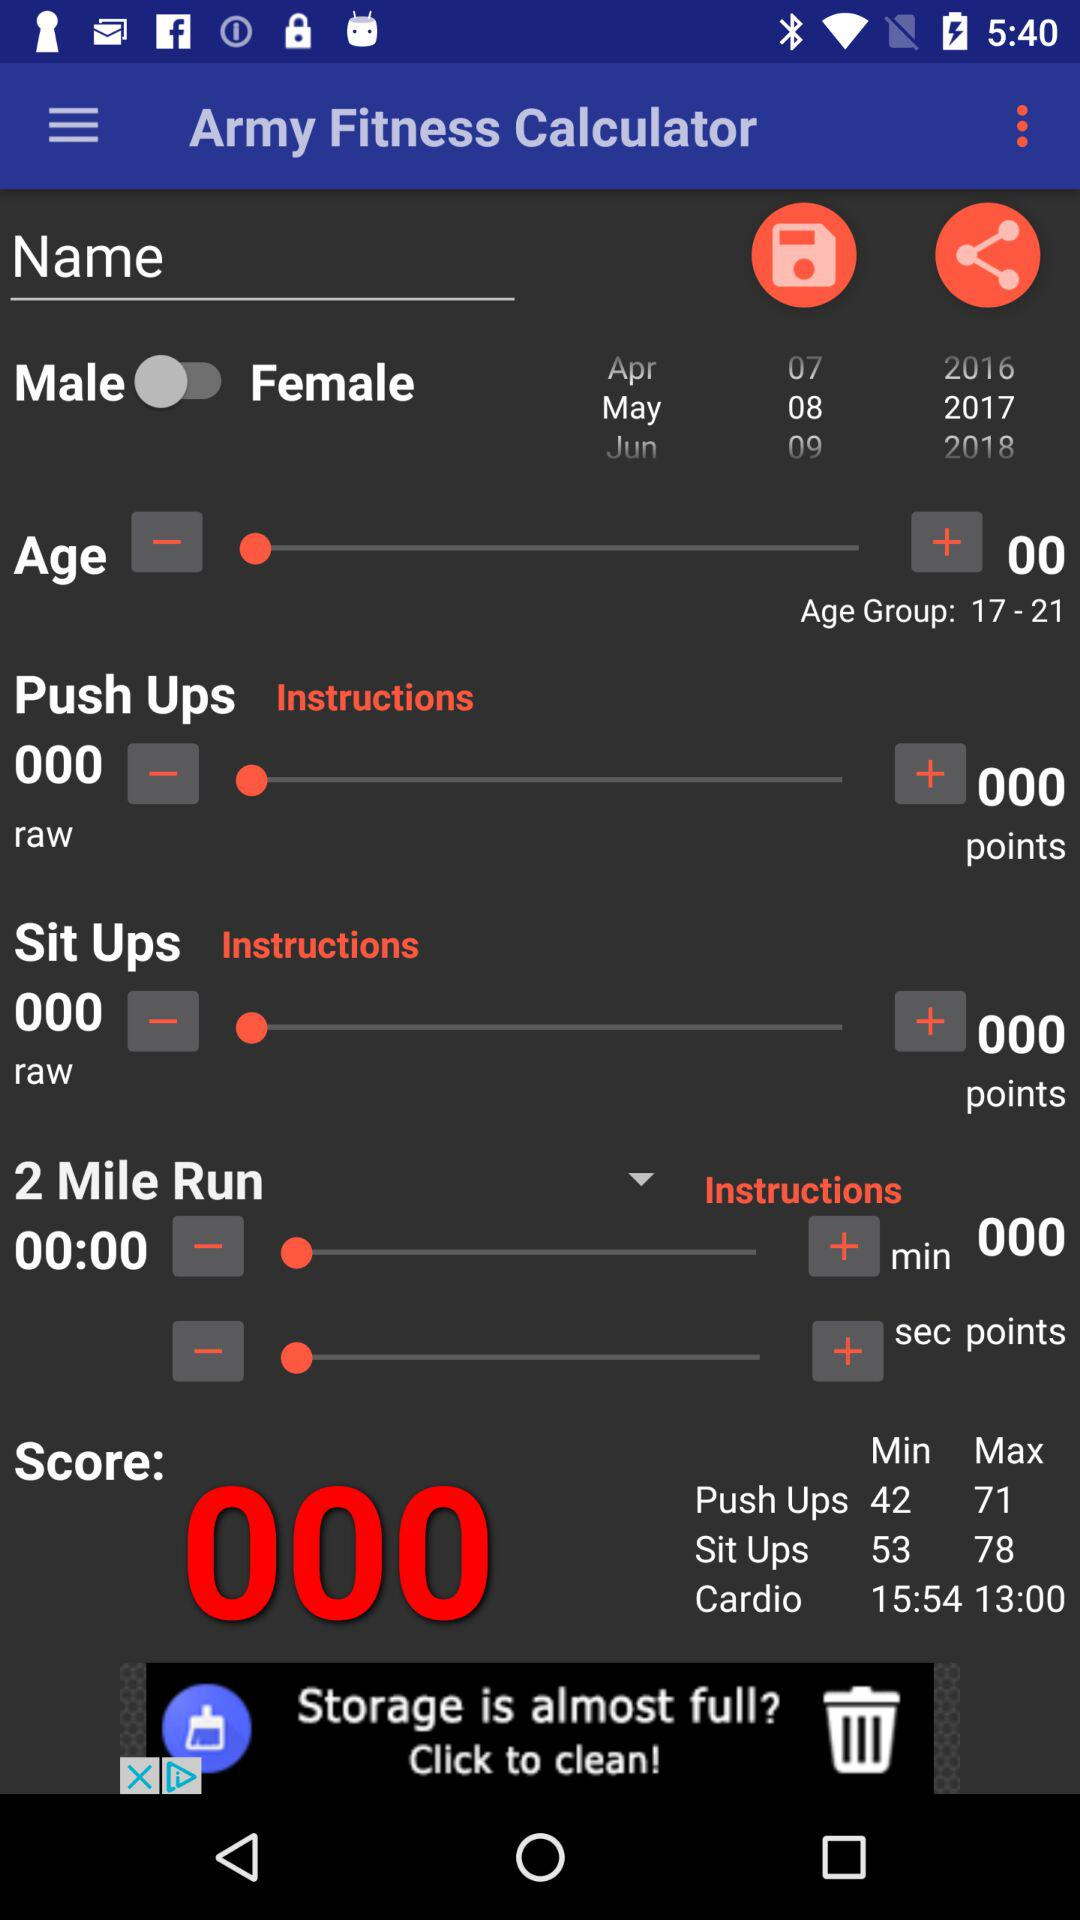Which date is selected? The selected date is May 8, 2017. 